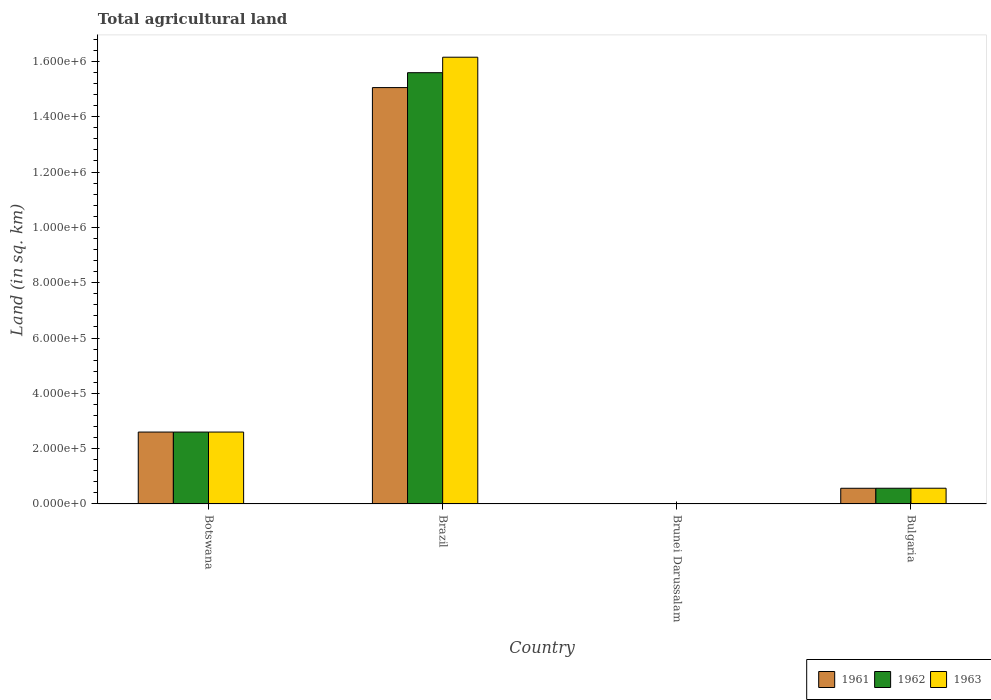How many different coloured bars are there?
Offer a terse response. 3. How many groups of bars are there?
Give a very brief answer. 4. Are the number of bars per tick equal to the number of legend labels?
Provide a short and direct response. Yes. Are the number of bars on each tick of the X-axis equal?
Your answer should be very brief. Yes. How many bars are there on the 2nd tick from the left?
Give a very brief answer. 3. How many bars are there on the 4th tick from the right?
Offer a terse response. 3. What is the label of the 4th group of bars from the left?
Offer a very short reply. Bulgaria. In how many cases, is the number of bars for a given country not equal to the number of legend labels?
Your response must be concise. 0. What is the total agricultural land in 1962 in Brunei Darussalam?
Provide a succinct answer. 210. Across all countries, what is the maximum total agricultural land in 1962?
Your answer should be compact. 1.56e+06. Across all countries, what is the minimum total agricultural land in 1961?
Your answer should be compact. 210. In which country was the total agricultural land in 1963 minimum?
Provide a short and direct response. Brunei Darussalam. What is the total total agricultural land in 1963 in the graph?
Make the answer very short. 1.93e+06. What is the difference between the total agricultural land in 1963 in Botswana and that in Brazil?
Ensure brevity in your answer.  -1.36e+06. What is the difference between the total agricultural land in 1962 in Bulgaria and the total agricultural land in 1961 in Brazil?
Ensure brevity in your answer.  -1.45e+06. What is the average total agricultural land in 1963 per country?
Your response must be concise. 4.83e+05. What is the difference between the total agricultural land of/in 1961 and total agricultural land of/in 1962 in Brunei Darussalam?
Keep it short and to the point. 0. What is the ratio of the total agricultural land in 1961 in Brunei Darussalam to that in Bulgaria?
Your answer should be very brief. 0. Is the total agricultural land in 1963 in Brazil less than that in Bulgaria?
Make the answer very short. No. What is the difference between the highest and the second highest total agricultural land in 1961?
Your answer should be very brief. 2.03e+05. What is the difference between the highest and the lowest total agricultural land in 1962?
Give a very brief answer. 1.56e+06. What does the 1st bar from the left in Bulgaria represents?
Provide a short and direct response. 1961. What does the 3rd bar from the right in Bulgaria represents?
Your answer should be compact. 1961. What is the difference between two consecutive major ticks on the Y-axis?
Your response must be concise. 2.00e+05. Are the values on the major ticks of Y-axis written in scientific E-notation?
Ensure brevity in your answer.  Yes. What is the title of the graph?
Give a very brief answer. Total agricultural land. Does "1972" appear as one of the legend labels in the graph?
Offer a terse response. No. What is the label or title of the X-axis?
Offer a very short reply. Country. What is the label or title of the Y-axis?
Make the answer very short. Land (in sq. km). What is the Land (in sq. km) in 1962 in Botswana?
Your response must be concise. 2.60e+05. What is the Land (in sq. km) of 1961 in Brazil?
Make the answer very short. 1.51e+06. What is the Land (in sq. km) of 1962 in Brazil?
Give a very brief answer. 1.56e+06. What is the Land (in sq. km) of 1963 in Brazil?
Offer a terse response. 1.62e+06. What is the Land (in sq. km) in 1961 in Brunei Darussalam?
Keep it short and to the point. 210. What is the Land (in sq. km) in 1962 in Brunei Darussalam?
Provide a succinct answer. 210. What is the Land (in sq. km) in 1963 in Brunei Darussalam?
Give a very brief answer. 210. What is the Land (in sq. km) of 1961 in Bulgaria?
Your response must be concise. 5.67e+04. What is the Land (in sq. km) of 1962 in Bulgaria?
Provide a succinct answer. 5.68e+04. What is the Land (in sq. km) of 1963 in Bulgaria?
Give a very brief answer. 5.69e+04. Across all countries, what is the maximum Land (in sq. km) of 1961?
Keep it short and to the point. 1.51e+06. Across all countries, what is the maximum Land (in sq. km) in 1962?
Your answer should be very brief. 1.56e+06. Across all countries, what is the maximum Land (in sq. km) in 1963?
Provide a short and direct response. 1.62e+06. Across all countries, what is the minimum Land (in sq. km) in 1961?
Your answer should be very brief. 210. Across all countries, what is the minimum Land (in sq. km) of 1962?
Your response must be concise. 210. Across all countries, what is the minimum Land (in sq. km) of 1963?
Keep it short and to the point. 210. What is the total Land (in sq. km) in 1961 in the graph?
Give a very brief answer. 1.82e+06. What is the total Land (in sq. km) in 1962 in the graph?
Your answer should be very brief. 1.88e+06. What is the total Land (in sq. km) in 1963 in the graph?
Offer a terse response. 1.93e+06. What is the difference between the Land (in sq. km) in 1961 in Botswana and that in Brazil?
Keep it short and to the point. -1.25e+06. What is the difference between the Land (in sq. km) of 1962 in Botswana and that in Brazil?
Your answer should be compact. -1.30e+06. What is the difference between the Land (in sq. km) of 1963 in Botswana and that in Brazil?
Keep it short and to the point. -1.36e+06. What is the difference between the Land (in sq. km) of 1961 in Botswana and that in Brunei Darussalam?
Provide a short and direct response. 2.60e+05. What is the difference between the Land (in sq. km) of 1962 in Botswana and that in Brunei Darussalam?
Your answer should be compact. 2.60e+05. What is the difference between the Land (in sq. km) of 1963 in Botswana and that in Brunei Darussalam?
Make the answer very short. 2.60e+05. What is the difference between the Land (in sq. km) in 1961 in Botswana and that in Bulgaria?
Provide a succinct answer. 2.03e+05. What is the difference between the Land (in sq. km) in 1962 in Botswana and that in Bulgaria?
Provide a short and direct response. 2.03e+05. What is the difference between the Land (in sq. km) in 1963 in Botswana and that in Bulgaria?
Make the answer very short. 2.03e+05. What is the difference between the Land (in sq. km) in 1961 in Brazil and that in Brunei Darussalam?
Provide a succinct answer. 1.51e+06. What is the difference between the Land (in sq. km) in 1962 in Brazil and that in Brunei Darussalam?
Offer a terse response. 1.56e+06. What is the difference between the Land (in sq. km) of 1963 in Brazil and that in Brunei Darussalam?
Offer a very short reply. 1.61e+06. What is the difference between the Land (in sq. km) of 1961 in Brazil and that in Bulgaria?
Ensure brevity in your answer.  1.45e+06. What is the difference between the Land (in sq. km) in 1962 in Brazil and that in Bulgaria?
Offer a terse response. 1.50e+06. What is the difference between the Land (in sq. km) in 1963 in Brazil and that in Bulgaria?
Provide a succinct answer. 1.56e+06. What is the difference between the Land (in sq. km) in 1961 in Brunei Darussalam and that in Bulgaria?
Offer a very short reply. -5.65e+04. What is the difference between the Land (in sq. km) in 1962 in Brunei Darussalam and that in Bulgaria?
Give a very brief answer. -5.66e+04. What is the difference between the Land (in sq. km) of 1963 in Brunei Darussalam and that in Bulgaria?
Make the answer very short. -5.67e+04. What is the difference between the Land (in sq. km) of 1961 in Botswana and the Land (in sq. km) of 1962 in Brazil?
Provide a succinct answer. -1.30e+06. What is the difference between the Land (in sq. km) in 1961 in Botswana and the Land (in sq. km) in 1963 in Brazil?
Ensure brevity in your answer.  -1.36e+06. What is the difference between the Land (in sq. km) of 1962 in Botswana and the Land (in sq. km) of 1963 in Brazil?
Provide a short and direct response. -1.36e+06. What is the difference between the Land (in sq. km) of 1961 in Botswana and the Land (in sq. km) of 1962 in Brunei Darussalam?
Your response must be concise. 2.60e+05. What is the difference between the Land (in sq. km) of 1961 in Botswana and the Land (in sq. km) of 1963 in Brunei Darussalam?
Provide a succinct answer. 2.60e+05. What is the difference between the Land (in sq. km) in 1962 in Botswana and the Land (in sq. km) in 1963 in Brunei Darussalam?
Keep it short and to the point. 2.60e+05. What is the difference between the Land (in sq. km) in 1961 in Botswana and the Land (in sq. km) in 1962 in Bulgaria?
Ensure brevity in your answer.  2.03e+05. What is the difference between the Land (in sq. km) in 1961 in Botswana and the Land (in sq. km) in 1963 in Bulgaria?
Provide a short and direct response. 2.03e+05. What is the difference between the Land (in sq. km) of 1962 in Botswana and the Land (in sq. km) of 1963 in Bulgaria?
Provide a short and direct response. 2.03e+05. What is the difference between the Land (in sq. km) of 1961 in Brazil and the Land (in sq. km) of 1962 in Brunei Darussalam?
Make the answer very short. 1.51e+06. What is the difference between the Land (in sq. km) in 1961 in Brazil and the Land (in sq. km) in 1963 in Brunei Darussalam?
Provide a succinct answer. 1.51e+06. What is the difference between the Land (in sq. km) of 1962 in Brazil and the Land (in sq. km) of 1963 in Brunei Darussalam?
Make the answer very short. 1.56e+06. What is the difference between the Land (in sq. km) in 1961 in Brazil and the Land (in sq. km) in 1962 in Bulgaria?
Provide a short and direct response. 1.45e+06. What is the difference between the Land (in sq. km) in 1961 in Brazil and the Land (in sq. km) in 1963 in Bulgaria?
Ensure brevity in your answer.  1.45e+06. What is the difference between the Land (in sq. km) of 1962 in Brazil and the Land (in sq. km) of 1963 in Bulgaria?
Give a very brief answer. 1.50e+06. What is the difference between the Land (in sq. km) in 1961 in Brunei Darussalam and the Land (in sq. km) in 1962 in Bulgaria?
Provide a succinct answer. -5.66e+04. What is the difference between the Land (in sq. km) in 1961 in Brunei Darussalam and the Land (in sq. km) in 1963 in Bulgaria?
Your answer should be very brief. -5.67e+04. What is the difference between the Land (in sq. km) in 1962 in Brunei Darussalam and the Land (in sq. km) in 1963 in Bulgaria?
Offer a terse response. -5.67e+04. What is the average Land (in sq. km) of 1961 per country?
Offer a very short reply. 4.56e+05. What is the average Land (in sq. km) of 1962 per country?
Ensure brevity in your answer.  4.69e+05. What is the average Land (in sq. km) in 1963 per country?
Offer a terse response. 4.83e+05. What is the difference between the Land (in sq. km) in 1961 and Land (in sq. km) in 1963 in Botswana?
Ensure brevity in your answer.  0. What is the difference between the Land (in sq. km) in 1962 and Land (in sq. km) in 1963 in Botswana?
Your answer should be very brief. 0. What is the difference between the Land (in sq. km) of 1961 and Land (in sq. km) of 1962 in Brazil?
Provide a succinct answer. -5.38e+04. What is the difference between the Land (in sq. km) in 1961 and Land (in sq. km) in 1963 in Brazil?
Give a very brief answer. -1.10e+05. What is the difference between the Land (in sq. km) of 1962 and Land (in sq. km) of 1963 in Brazil?
Provide a short and direct response. -5.60e+04. What is the difference between the Land (in sq. km) in 1961 and Land (in sq. km) in 1963 in Brunei Darussalam?
Provide a succinct answer. 0. What is the difference between the Land (in sq. km) of 1962 and Land (in sq. km) of 1963 in Brunei Darussalam?
Give a very brief answer. 0. What is the difference between the Land (in sq. km) of 1961 and Land (in sq. km) of 1962 in Bulgaria?
Provide a succinct answer. -120. What is the difference between the Land (in sq. km) of 1961 and Land (in sq. km) of 1963 in Bulgaria?
Offer a terse response. -200. What is the difference between the Land (in sq. km) in 1962 and Land (in sq. km) in 1963 in Bulgaria?
Make the answer very short. -80. What is the ratio of the Land (in sq. km) of 1961 in Botswana to that in Brazil?
Give a very brief answer. 0.17. What is the ratio of the Land (in sq. km) in 1962 in Botswana to that in Brazil?
Ensure brevity in your answer.  0.17. What is the ratio of the Land (in sq. km) in 1963 in Botswana to that in Brazil?
Keep it short and to the point. 0.16. What is the ratio of the Land (in sq. km) in 1961 in Botswana to that in Brunei Darussalam?
Offer a very short reply. 1238.1. What is the ratio of the Land (in sq. km) of 1962 in Botswana to that in Brunei Darussalam?
Ensure brevity in your answer.  1238.1. What is the ratio of the Land (in sq. km) of 1963 in Botswana to that in Brunei Darussalam?
Offer a very short reply. 1238.1. What is the ratio of the Land (in sq. km) of 1961 in Botswana to that in Bulgaria?
Ensure brevity in your answer.  4.58. What is the ratio of the Land (in sq. km) in 1962 in Botswana to that in Bulgaria?
Make the answer very short. 4.57. What is the ratio of the Land (in sq. km) of 1963 in Botswana to that in Bulgaria?
Offer a very short reply. 4.57. What is the ratio of the Land (in sq. km) in 1961 in Brazil to that in Brunei Darussalam?
Ensure brevity in your answer.  7168.14. What is the ratio of the Land (in sq. km) of 1962 in Brazil to that in Brunei Darussalam?
Ensure brevity in your answer.  7424.43. What is the ratio of the Land (in sq. km) in 1963 in Brazil to that in Brunei Darussalam?
Offer a very short reply. 7691. What is the ratio of the Land (in sq. km) in 1961 in Brazil to that in Bulgaria?
Your answer should be compact. 26.53. What is the ratio of the Land (in sq. km) in 1962 in Brazil to that in Bulgaria?
Your answer should be compact. 27.43. What is the ratio of the Land (in sq. km) of 1963 in Brazil to that in Bulgaria?
Keep it short and to the point. 28.37. What is the ratio of the Land (in sq. km) in 1961 in Brunei Darussalam to that in Bulgaria?
Offer a very short reply. 0. What is the ratio of the Land (in sq. km) in 1962 in Brunei Darussalam to that in Bulgaria?
Your answer should be very brief. 0. What is the ratio of the Land (in sq. km) of 1963 in Brunei Darussalam to that in Bulgaria?
Ensure brevity in your answer.  0. What is the difference between the highest and the second highest Land (in sq. km) of 1961?
Offer a very short reply. 1.25e+06. What is the difference between the highest and the second highest Land (in sq. km) in 1962?
Keep it short and to the point. 1.30e+06. What is the difference between the highest and the second highest Land (in sq. km) in 1963?
Offer a very short reply. 1.36e+06. What is the difference between the highest and the lowest Land (in sq. km) in 1961?
Your response must be concise. 1.51e+06. What is the difference between the highest and the lowest Land (in sq. km) in 1962?
Offer a very short reply. 1.56e+06. What is the difference between the highest and the lowest Land (in sq. km) of 1963?
Provide a succinct answer. 1.61e+06. 